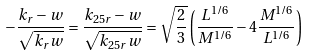Convert formula to latex. <formula><loc_0><loc_0><loc_500><loc_500>- \frac { k _ { r } - w } { \sqrt { k _ { r } w } } = \frac { k _ { 2 5 r } - w } { \sqrt { k _ { 2 5 r } w } } = \sqrt { \frac { 2 } { 3 } } \left ( \frac { L ^ { 1 / 6 } } { M ^ { 1 / 6 } } - 4 \frac { M ^ { 1 / 6 } } { L ^ { 1 / 6 } } \right )</formula> 